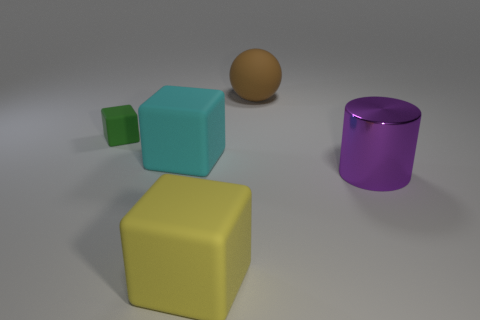Are there any other things that have the same material as the purple object?
Make the answer very short. No. Is there anything else that has the same size as the green thing?
Provide a succinct answer. No. There is a block that is behind the purple cylinder and right of the green rubber object; what color is it?
Your answer should be compact. Cyan. Is the material of the big block that is in front of the large purple cylinder the same as the big thing that is to the right of the large ball?
Your answer should be very brief. No. Are there more balls in front of the tiny rubber object than green cubes on the right side of the large purple metallic thing?
Make the answer very short. No. The brown object that is the same size as the metallic cylinder is what shape?
Your response must be concise. Sphere. What number of things are either small purple matte objects or big cubes that are behind the big yellow rubber block?
Keep it short and to the point. 1. There is a shiny cylinder; how many blocks are in front of it?
Provide a succinct answer. 1. There is a sphere that is the same material as the tiny object; what is its color?
Provide a succinct answer. Brown. What number of rubber objects are cubes or purple things?
Your answer should be compact. 3. 